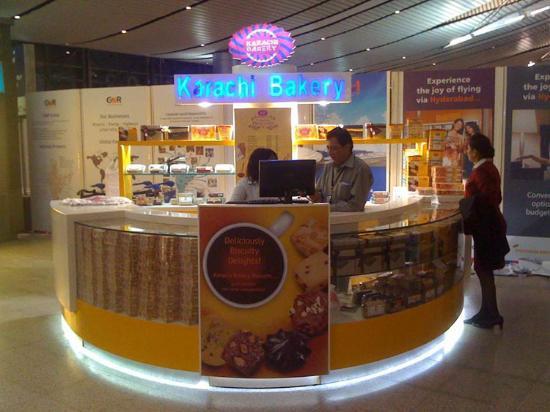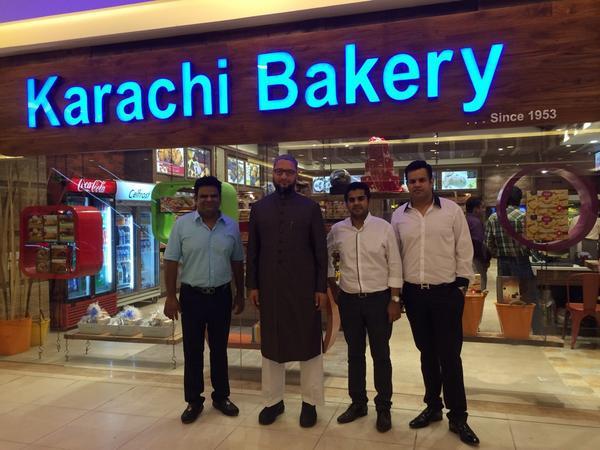The first image is the image on the left, the second image is the image on the right. For the images displayed, is the sentence "There is at least one person in front of a store in the right image." factually correct? Answer yes or no. Yes. 